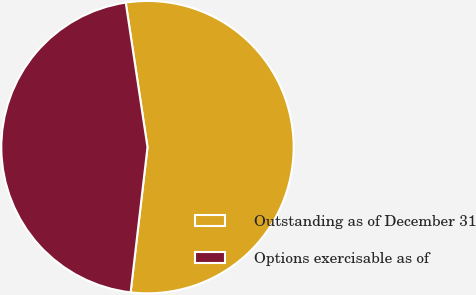<chart> <loc_0><loc_0><loc_500><loc_500><pie_chart><fcel>Outstanding as of December 31<fcel>Options exercisable as of<nl><fcel>54.22%<fcel>45.78%<nl></chart> 